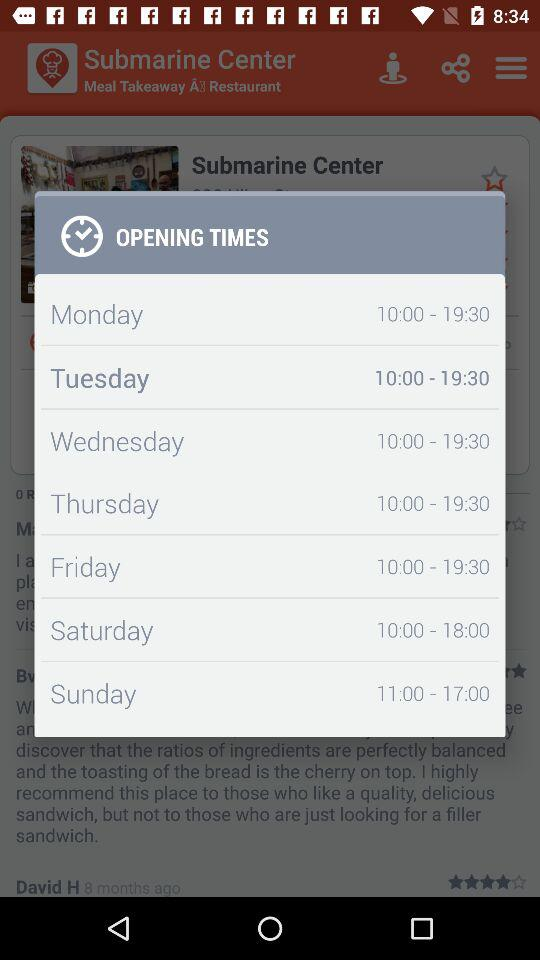Which day is highlighted? The highlighted day is Tuesday. 